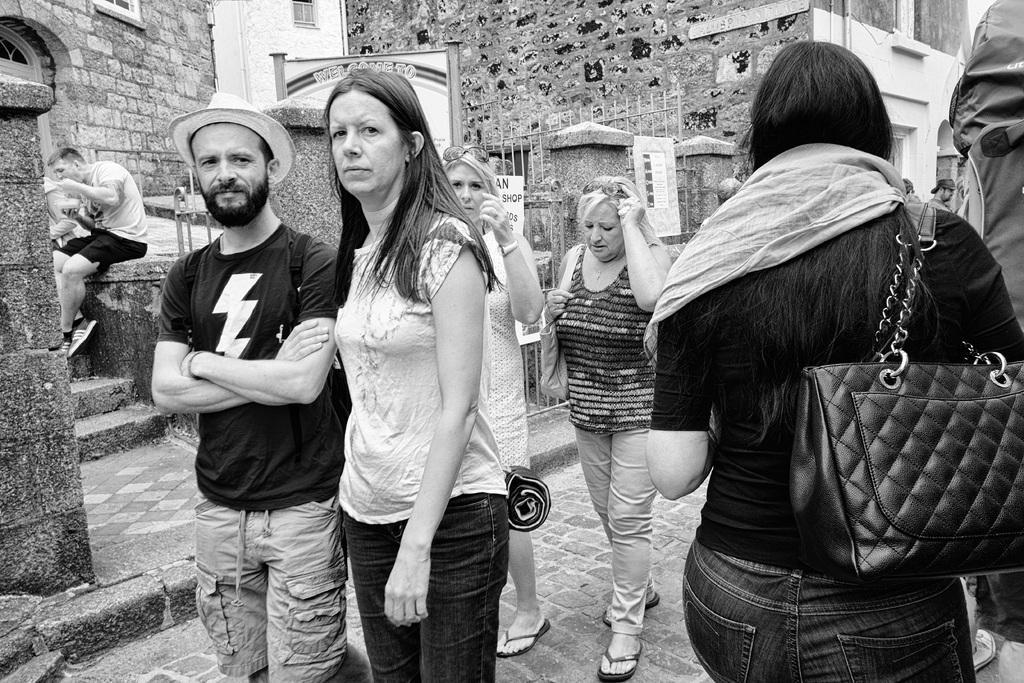Please provide a concise description of this image. There is a couple standing on the left side and they are posing for a photo. In the background we can see three women who are walking on a road. There is a person sitting here and he is eating. 